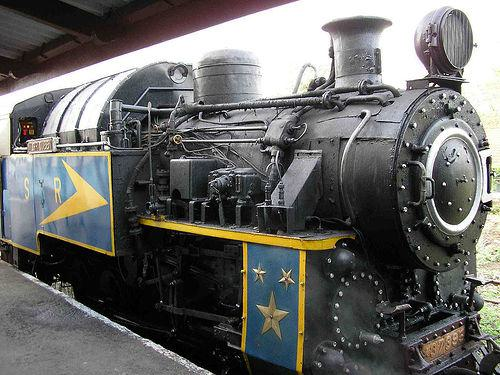What features of this train make it distinct from modern trains? Distinct features include the large, prominent steam engine with a smokestack, external piping, riveting details, and its overall metal construction, which differs significantly from the sleek, electric or diesel-powered trains of today. 